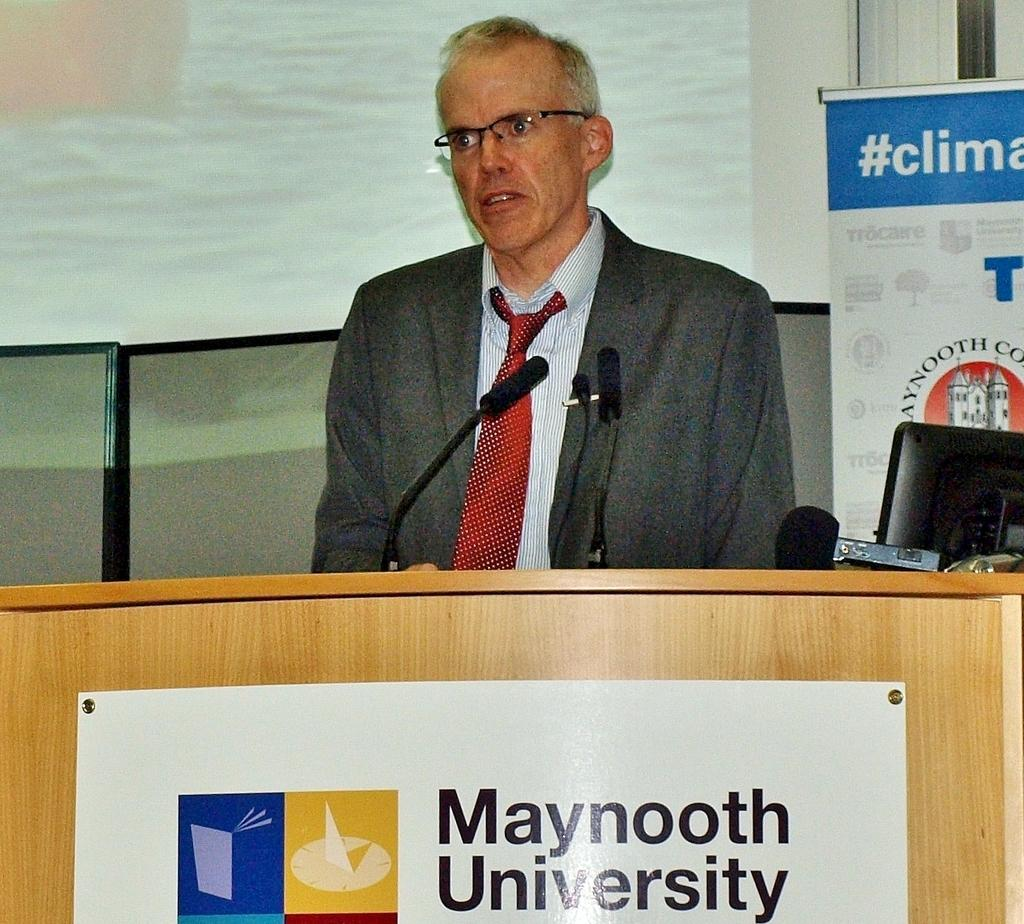<image>
Offer a succinct explanation of the picture presented. Person giving a speech in front of a podium that says Maynooth University. 